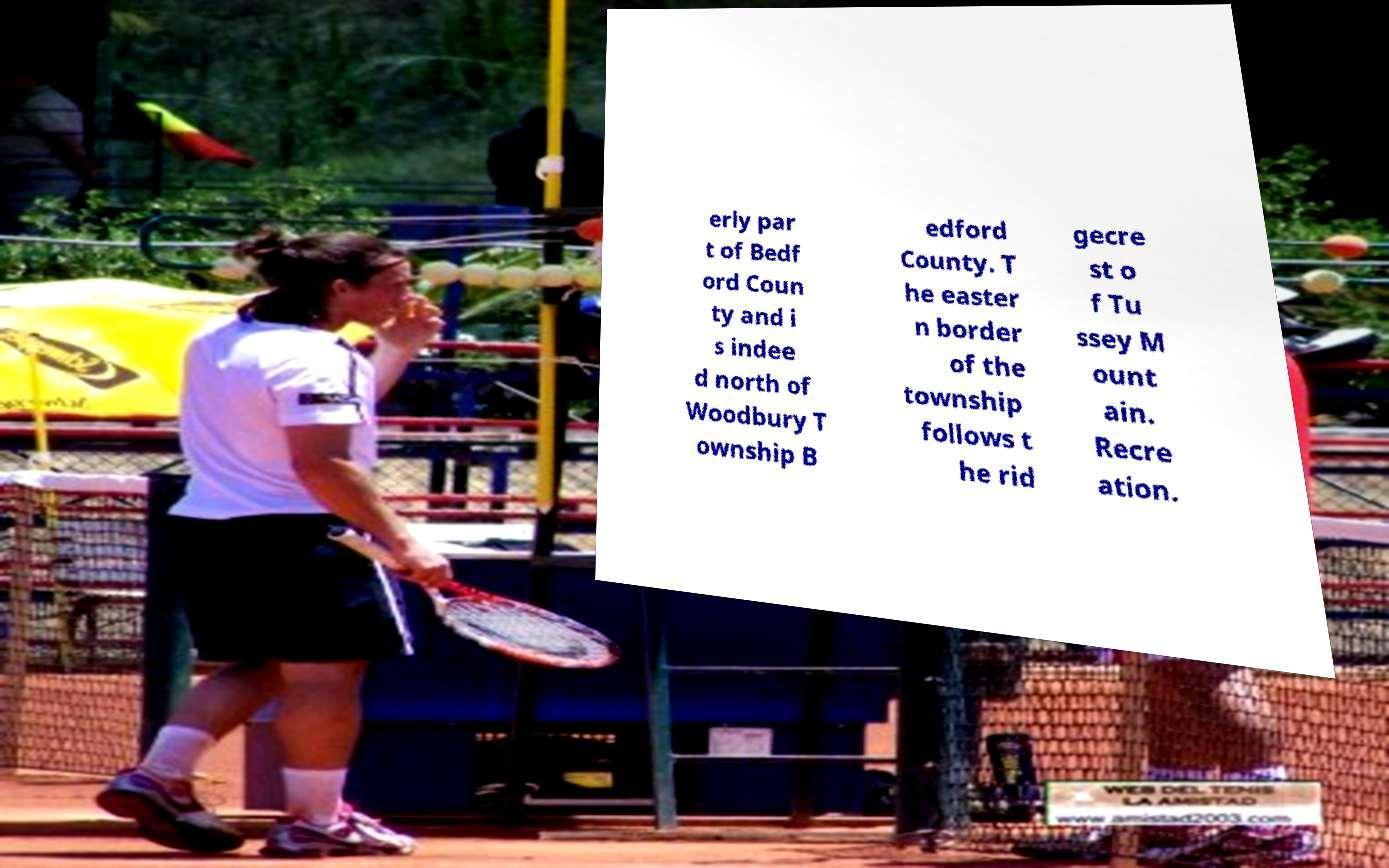Please read and relay the text visible in this image. What does it say? erly par t of Bedf ord Coun ty and i s indee d north of Woodbury T ownship B edford County. T he easter n border of the township follows t he rid gecre st o f Tu ssey M ount ain. Recre ation. 